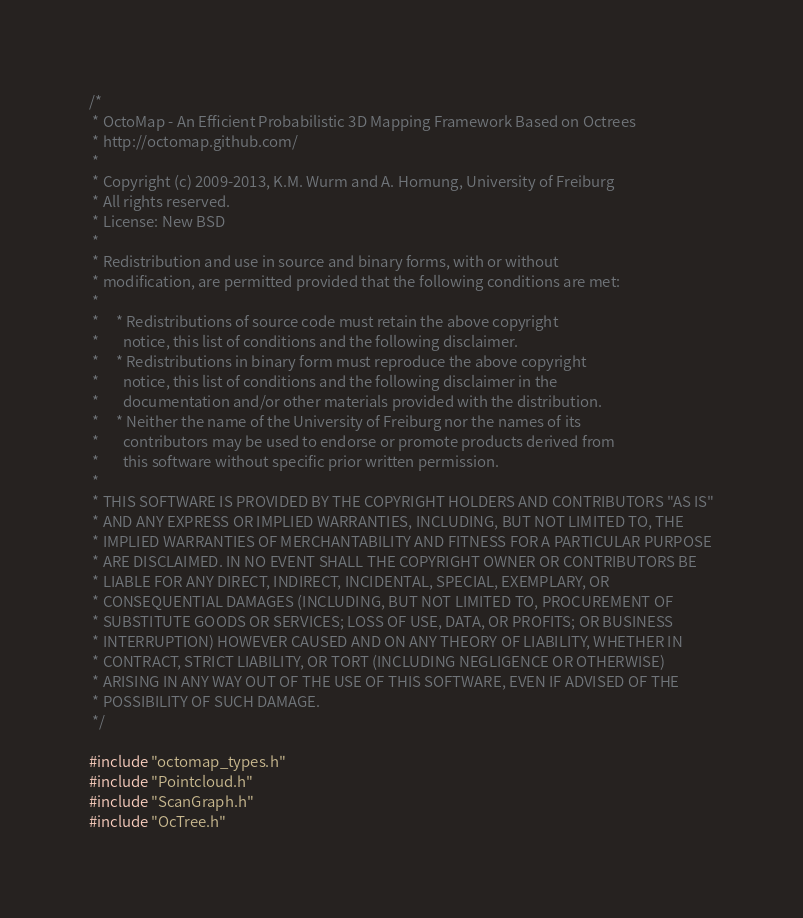Convert code to text. <code><loc_0><loc_0><loc_500><loc_500><_C_>/*
 * OctoMap - An Efficient Probabilistic 3D Mapping Framework Based on Octrees
 * http://octomap.github.com/
 *
 * Copyright (c) 2009-2013, K.M. Wurm and A. Hornung, University of Freiburg
 * All rights reserved.
 * License: New BSD
 *
 * Redistribution and use in source and binary forms, with or without
 * modification, are permitted provided that the following conditions are met:
 *
 *     * Redistributions of source code must retain the above copyright
 *       notice, this list of conditions and the following disclaimer.
 *     * Redistributions in binary form must reproduce the above copyright
 *       notice, this list of conditions and the following disclaimer in the
 *       documentation and/or other materials provided with the distribution.
 *     * Neither the name of the University of Freiburg nor the names of its
 *       contributors may be used to endorse or promote products derived from
 *       this software without specific prior written permission.
 *
 * THIS SOFTWARE IS PROVIDED BY THE COPYRIGHT HOLDERS AND CONTRIBUTORS "AS IS"
 * AND ANY EXPRESS OR IMPLIED WARRANTIES, INCLUDING, BUT NOT LIMITED TO, THE
 * IMPLIED WARRANTIES OF MERCHANTABILITY AND FITNESS FOR A PARTICULAR PURPOSE
 * ARE DISCLAIMED. IN NO EVENT SHALL THE COPYRIGHT OWNER OR CONTRIBUTORS BE
 * LIABLE FOR ANY DIRECT, INDIRECT, INCIDENTAL, SPECIAL, EXEMPLARY, OR
 * CONSEQUENTIAL DAMAGES (INCLUDING, BUT NOT LIMITED TO, PROCUREMENT OF
 * SUBSTITUTE GOODS OR SERVICES; LOSS OF USE, DATA, OR PROFITS; OR BUSINESS
 * INTERRUPTION) HOWEVER CAUSED AND ON ANY THEORY OF LIABILITY, WHETHER IN
 * CONTRACT, STRICT LIABILITY, OR TORT (INCLUDING NEGLIGENCE OR OTHERWISE)
 * ARISING IN ANY WAY OUT OF THE USE OF THIS SOFTWARE, EVEN IF ADVISED OF THE
 * POSSIBILITY OF SUCH DAMAGE.
 */

#include "octomap_types.h"
#include "Pointcloud.h"
#include "ScanGraph.h"
#include "OcTree.h"

</code> 